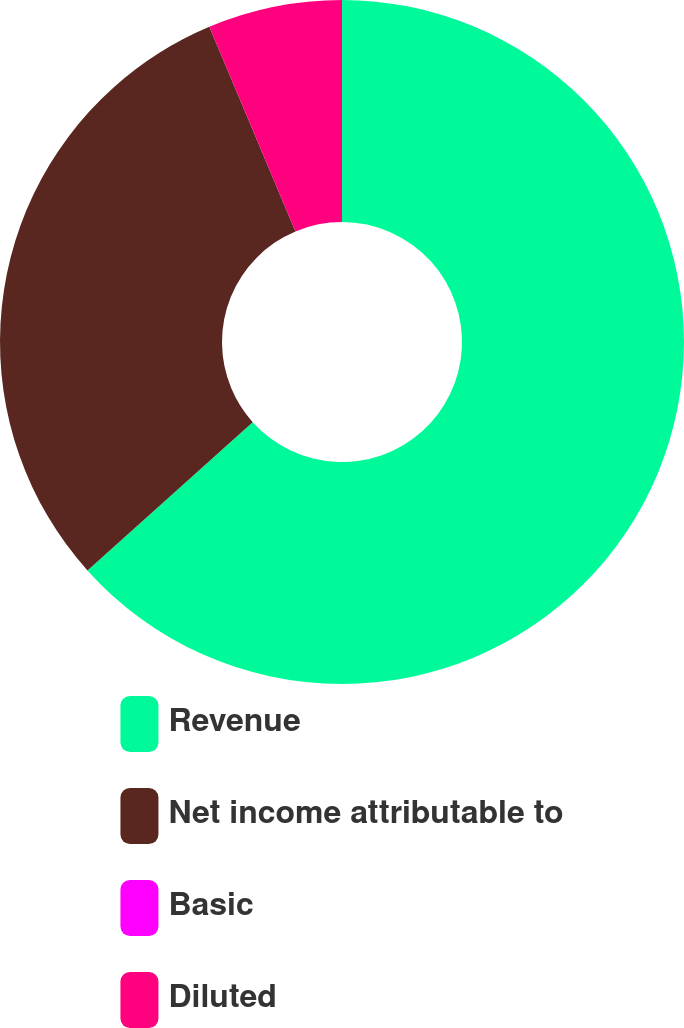<chart> <loc_0><loc_0><loc_500><loc_500><pie_chart><fcel>Revenue<fcel>Net income attributable to<fcel>Basic<fcel>Diluted<nl><fcel>63.36%<fcel>30.3%<fcel>0.0%<fcel>6.34%<nl></chart> 